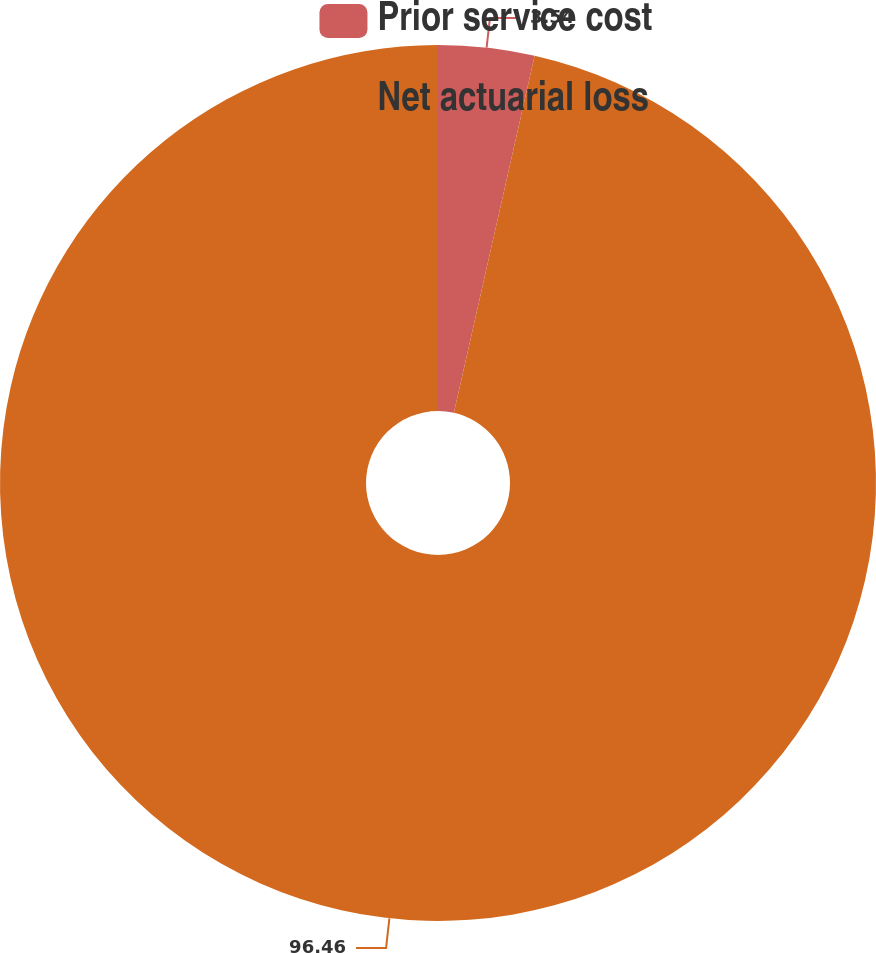Convert chart to OTSL. <chart><loc_0><loc_0><loc_500><loc_500><pie_chart><fcel>Prior service cost<fcel>Net actuarial loss<nl><fcel>3.54%<fcel>96.46%<nl></chart> 